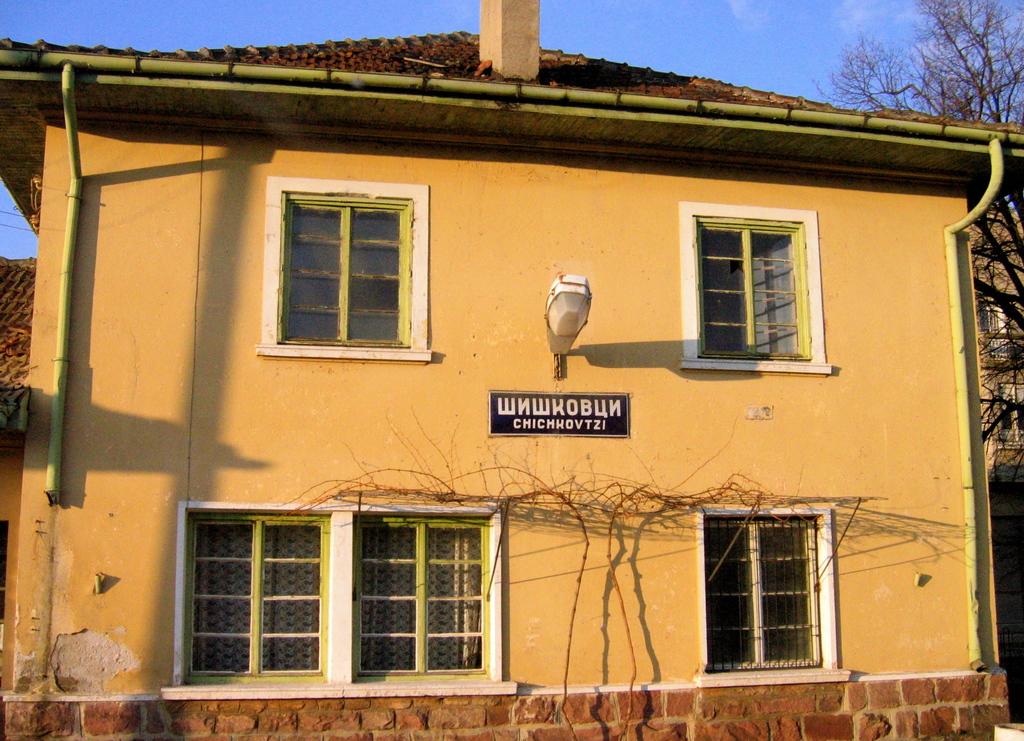What is the 2nd word on this sign?
Your answer should be compact. Chichkovtzi. 